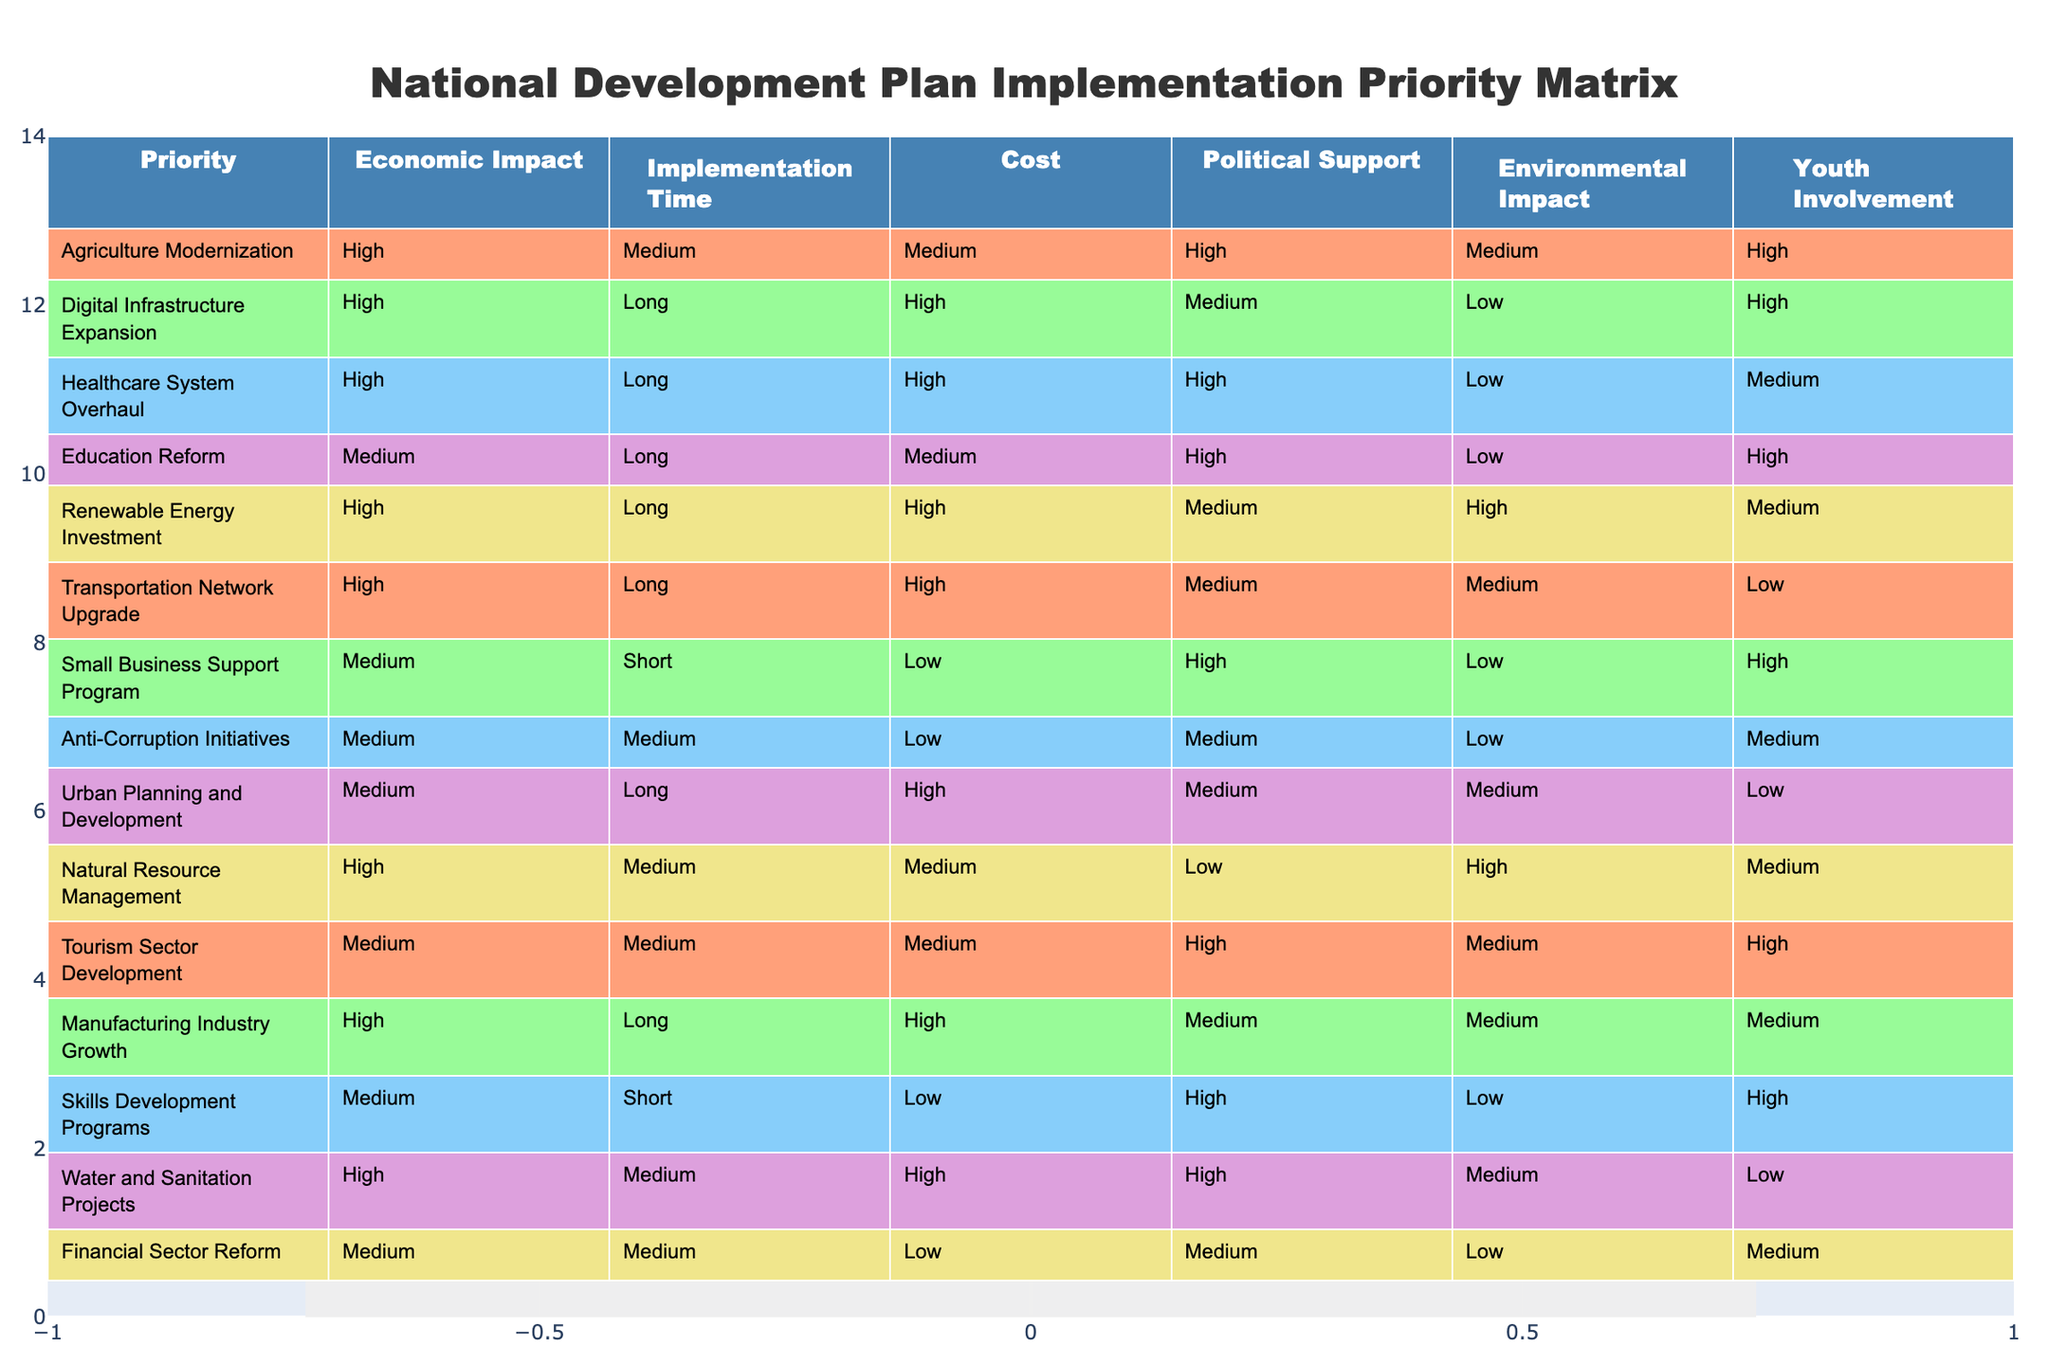What is the cost associated with the Healthcare System Overhaul? Looking at the table, the row for "Healthcare System Overhaul" indicates that the cost is categorized as "High".
Answer: High Which priority has the highest economic impact? By examining the "Economic Impact" column, we find that multiple priorities have been marked as "High". However, "Agriculture Modernization," "Digital Infrastructure Expansion," "Healthcare System Overhaul," "Renewable Energy Investment," "Transportation Network Upgrade," "Natural Resource Management," and "Manufacturing Industry Growth" all have a "High" economic impact.
Answer: Agriculture Modernization, Digital Infrastructure Expansion, Healthcare System Overhaul, Renewable Energy Investment, Transportation Network Upgrade, Natural Resource Management, Manufacturing Industry Growth Is there any priority that combines a high political support and a low environmental impact? By looking at both the "Political Support" and "Environmental Impact" columns, we can see that the "Small Business Support Program" has high political support but the environmental impact is low.
Answer: Yes What percentage of priorities have medium implementation time? There are a total of 12 priorities, and 3 of them are marked as "Medium" in the "Implementation Time" column: "Agriculture Modernization," "Natural Resource Management," and "Anti-Corruption Initiatives." To find the percentage, we calculate (3/12) * 100 = 25%.
Answer: 25% Which priority involves the most youth involvement? Reviewing the "Youth Involvement" column, we find that "Agriculture Modernization," "Digital Infrastructure Expansion," "Education Reform," "Small Business Support Program," and "Skills Development Programs" are all categorized as "High" for youth involvement.
Answer: Agriculture Modernization, Digital Infrastructure Expansion, Education Reform, Small Business Support Program, Skills Development Programs What are the cost implications for initiatives with long implementation times? From the table, several priorities with "Long" implementation times include "Healthcare System Overhaul," "Education Reform," "Digital Infrastructure Expansion," "Renewable Energy Investment," "Transportation Network Upgrade," and "Manufacturing Industry Growth," all of which have "High" costs. Thus, we see a trend where most long-term initiatives have higher costs.
Answer: High costs What is the average cost level of priorities marked with a medium economic impact? The priorities categorized under "Medium" economic impact include "Education Reform," "Small Business Support Program," "Anti-Corruption Initiatives," "Urban Planning and Development," and "Tourism Sector Development." The costs for these initiatives are: Education Reform (Medium), Small Business Support Program (Low), Anti-Corruption Initiatives (Low), Urban Planning and Development (High), and Tourism Sector Development (Medium). Totaling these up, we have 1 High, 2 Medium, and 2 Low. Given the levels, we can assign Low = 1, Medium = 2, High = 3 for calculation. Hence, the average cost is (1+2+2+3+2)/5 = 2 (Medium).
Answer: Medium Does the Renewable Energy Investment have any youth involvement? By checking the row for "Renewable Energy Investment," we see that it has a youth involvement level marked as "Medium".
Answer: Yes 